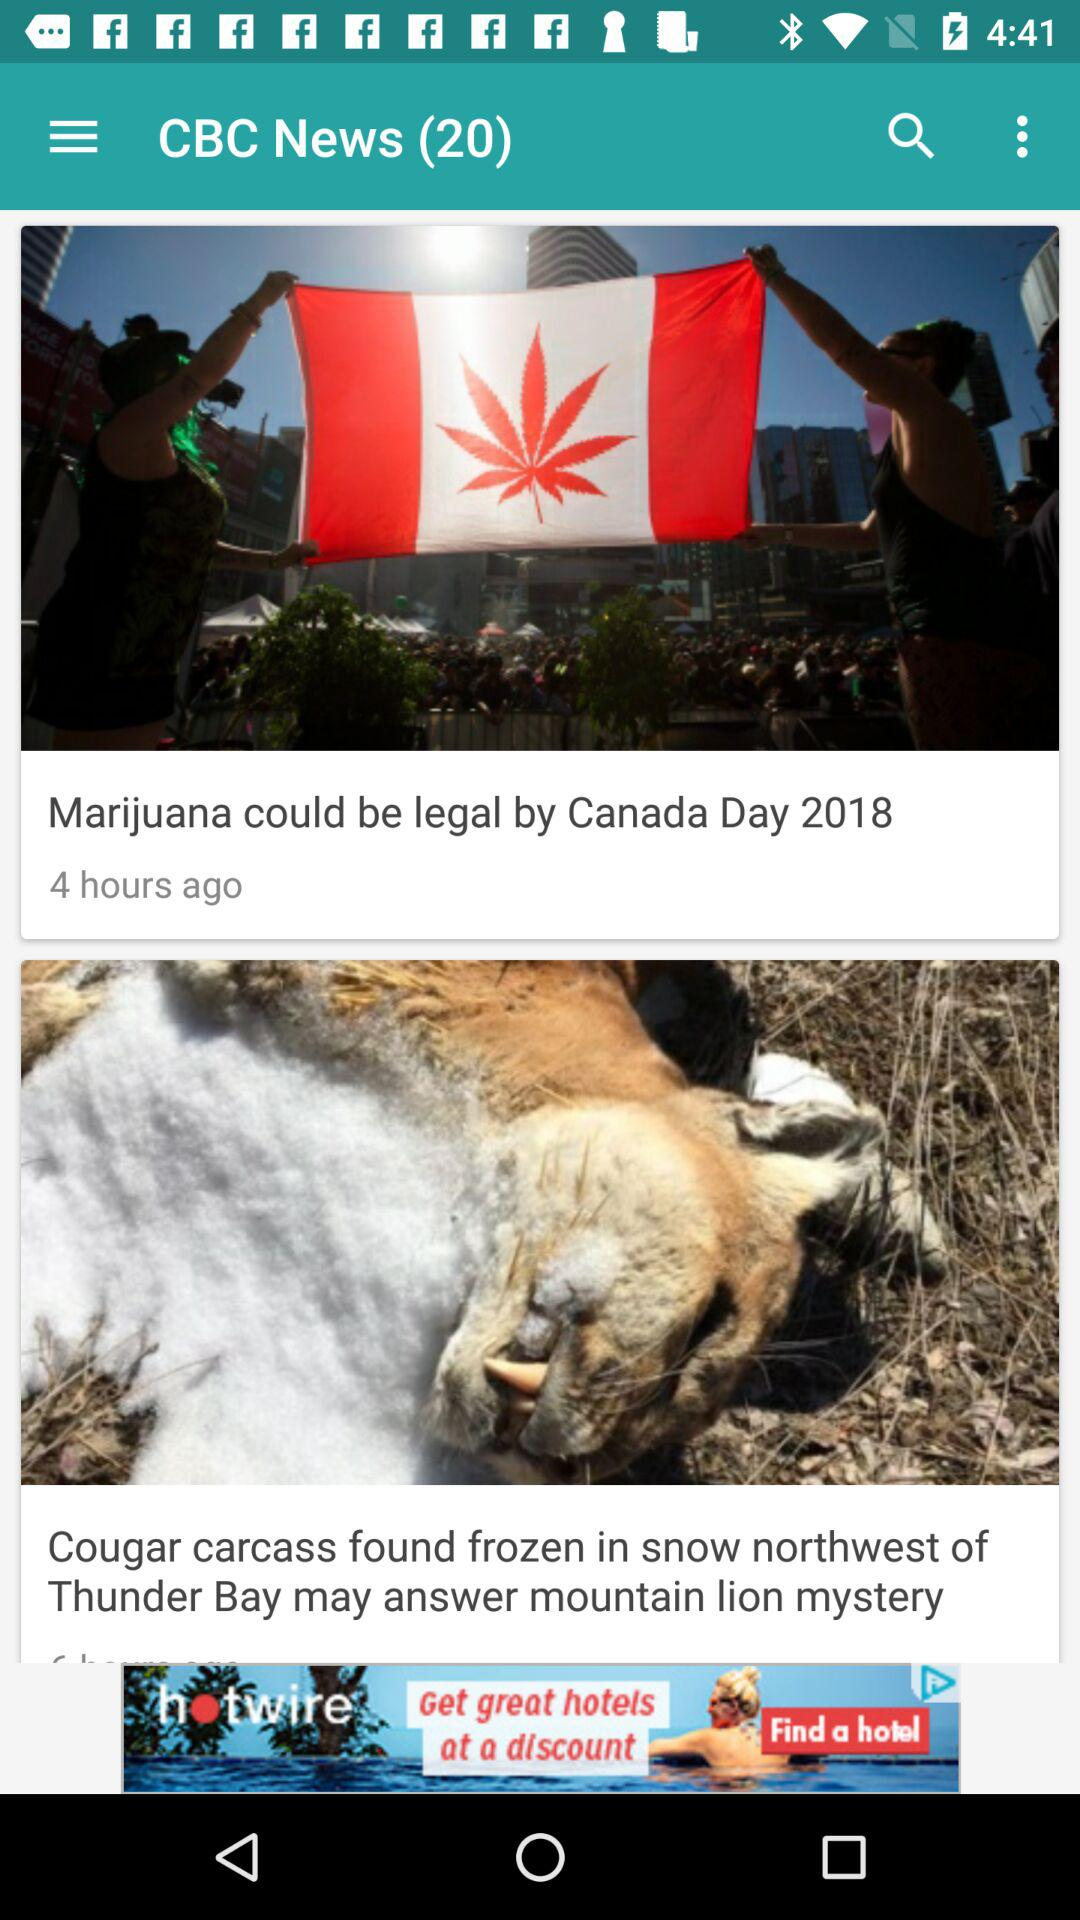How many news are there? There are 20 news. 